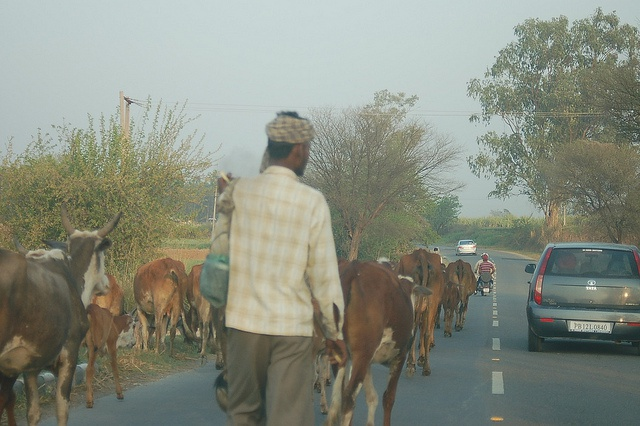Describe the objects in this image and their specific colors. I can see people in lightgray, tan, and gray tones, cow in lightgray, gray, and black tones, car in lightgray, gray, purple, black, and darkgray tones, cow in lightgray, gray, and black tones, and cow in lightgray, gray, and tan tones in this image. 